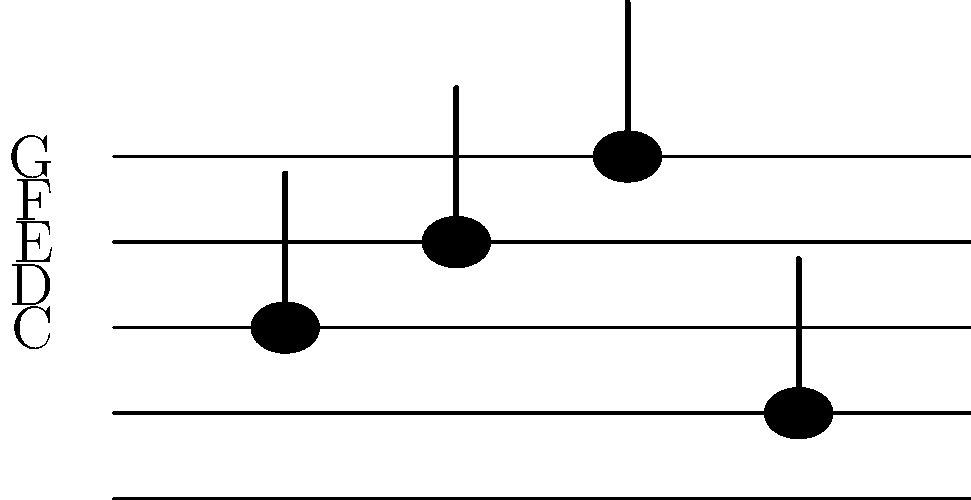As a music blogger and Terence Trent D'Arby enthusiast, you're analyzing sheet music. Identify the sequence of notes shown on this staff, starting from left to right. To identify the sequence of notes, let's follow these steps:

1. Recognize the staff: The image shows a standard 5-line staff.

2. Identify the reference line: The bottom line of the staff represents the note E.

3. Count lines and spaces:
   - Each line and space represents a note in alphabetical order (E, F, G, A, B, C, D, E, F, G).

4. Analyze each note from left to right:
   - First note: On the second line from the bottom, which is G.
   - Second note: In the space above the second line, which is A.
   - Third note: On the top line, which is F.
   - Fourth note: In the space below the bottom line, which is D.

5. Combine the notes in sequence: G, A, F, D.

This sequence might remind a Terence Trent D'Arby fan of the opening notes from one of his songs, adding an interesting perspective to your music blog analysis.
Answer: G, A, F, D 